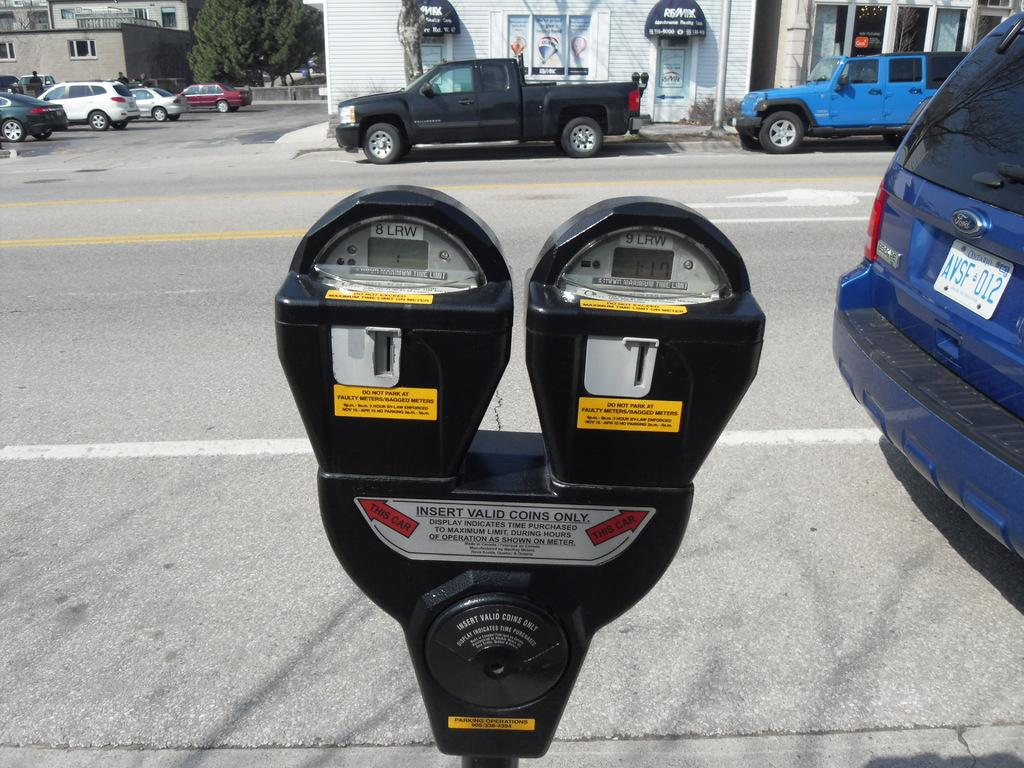<image>
Offer a succinct explanation of the picture presented. A blue van with Ontario license plates is parked near a parking meter. 